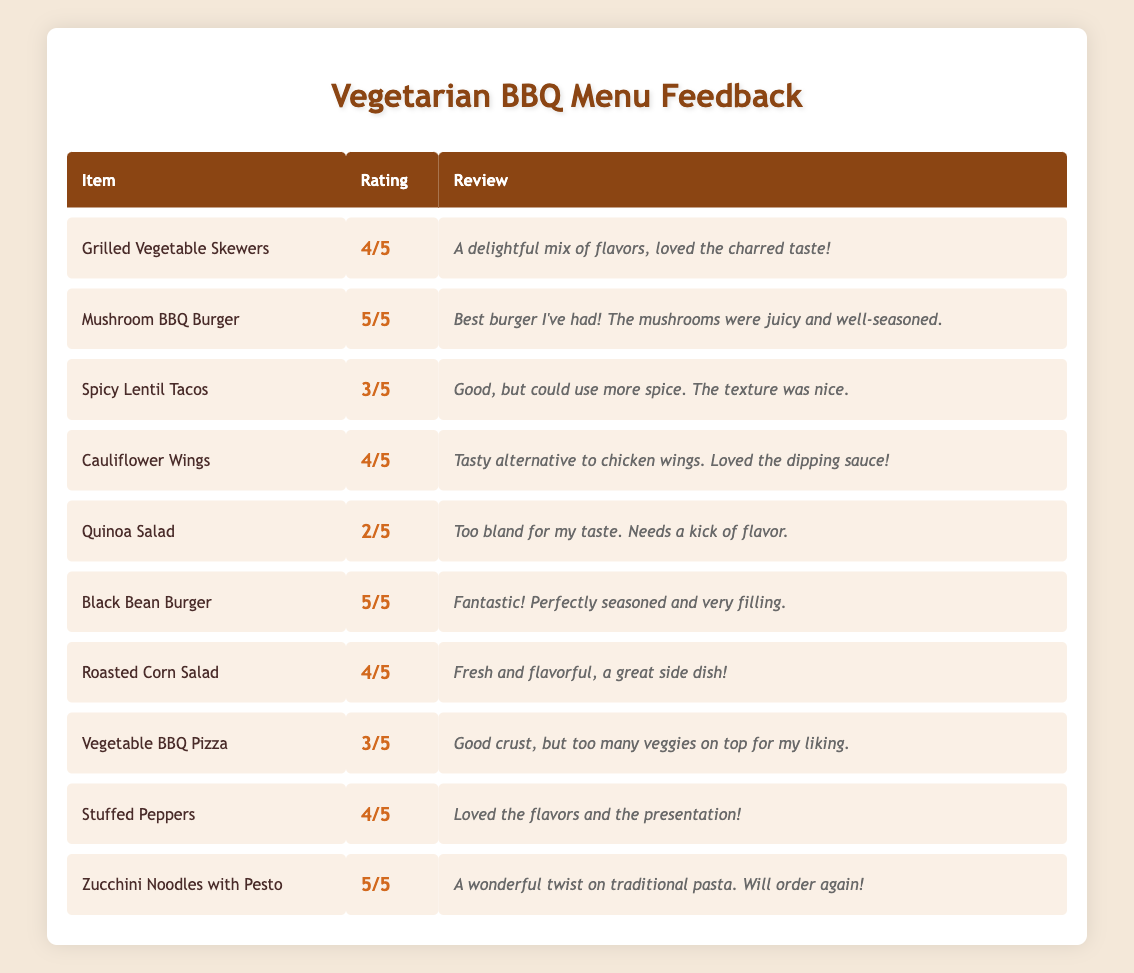What is the highest-rated vegetarian menu item? The ratings are as follows: Grilled Vegetable Skewers (4), Mushroom BBQ Burger (5), Spicy Lentil Tacos (3), Cauliflower Wings (4), Quinoa Salad (2), Black Bean Burger (5), Roasted Corn Salad (4), Vegetable BBQ Pizza (3), Stuffed Peppers (4), Zucchini Noodles with Pesto (5). The highest rating of 5 appears for Mushroom BBQ Burger, Black Bean Burger, and Zucchini Noodles with Pesto.
Answer: Mushroom BBQ Burger, Black Bean Burger, Zucchini Noodles with Pesto How many items received a rating of 4 or above? The items with ratings of 4 or above are: Grilled Vegetable Skewers (4), Mushroom BBQ Burger (5), Cauliflower Wings (4), Black Bean Burger (5), Roasted Corn Salad (4), Stuffed Peppers (4), and Zucchini Noodles with Pesto (5). Counting these gives us 7 items.
Answer: 7 What is the average rating of all vegetarian items? The total ratings are: 4 + 5 + 3 + 4 + 2 + 5 + 4 + 3 + 4 + 5 = 43. There are 10 items, so the average rating is 43/10 = 4.3.
Answer: 4.3 Which item had the least favorable review? The item with the lowest rating is Quinoa Salad with a rating of 2. The review states that it was "too bland for my taste."
Answer: Quinoa Salad Is there any item that received a rating of 3? The items with a rating of 3 are Spicy Lentil Tacos and Vegetable BBQ Pizza. Both these items received a middle rating in the overall feedback.
Answer: Yes How many items received a higher rating than the Spicy Lentil Tacos? The Spicy Lentil Tacos received a rating of 3. The items with higher ratings are: Grilled Vegetable Skewers (4), Mushroom BBQ Burger (5), Cauliflower Wings (4), Black Bean Burger (5), Roasted Corn Salad (4), Stuffed Peppers (4), and Zucchini Noodles with Pesto (5). Counting these gives us 7 items.
Answer: 7 What percentage of the items are rated below 4? The items rated below 4 are: Spicy Lentil Tacos (3), Quinoa Salad (2), and Vegetable BBQ Pizza (3). That makes a total of 3 items. Therefore, the percentage is (3 out of 10) x 100 = 30%.
Answer: 30% Which item had the longest positive review? To determine the longest positive review, we look at the reviews: "A delightful mix of flavors, loved the charred taste!" (Grilled Vegetable Skewers), "Best burger I've had! The mushrooms were juicy and well-seasoned." (Mushroom BBQ Burger), and others. The longest review is "Best burger I've had! The mushrooms were juicy and well-seasoned." from the Mushroom BBQ Burger.
Answer: Mushroom BBQ Burger How many items are rated the same as the Cauliflower Wings? The Cauliflower Wings have a rating of 4. The items with the same rating are: Grilled Vegetable Skewers (4), Black Bean Burger (5), Roasted Corn Salad (4), Stuffed Peppers (4), and Zucchini Noodles with Pesto (5). Counting these gives us 4 items rated 4.
Answer: 4 